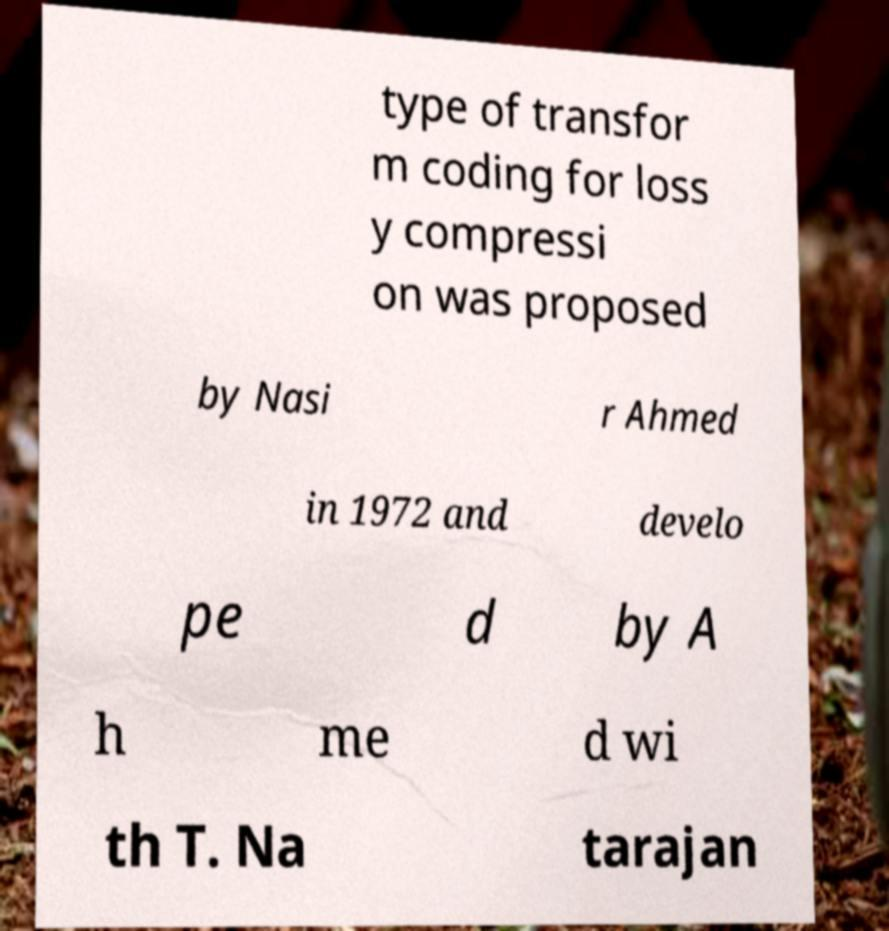Could you extract and type out the text from this image? type of transfor m coding for loss y compressi on was proposed by Nasi r Ahmed in 1972 and develo pe d by A h me d wi th T. Na tarajan 